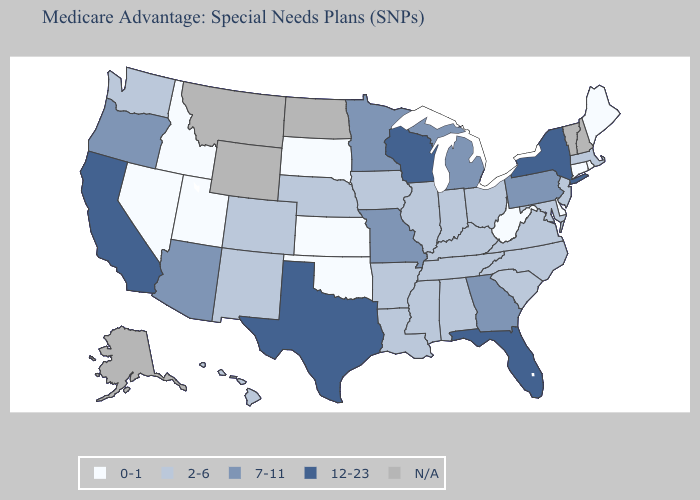Name the states that have a value in the range 12-23?
Answer briefly. California, Florida, New York, Texas, Wisconsin. Among the states that border California , does Nevada have the highest value?
Keep it brief. No. What is the value of Florida?
Short answer required. 12-23. What is the value of Georgia?
Give a very brief answer. 7-11. What is the lowest value in the USA?
Give a very brief answer. 0-1. Which states have the lowest value in the MidWest?
Be succinct. Kansas, South Dakota. Does the map have missing data?
Write a very short answer. Yes. Name the states that have a value in the range N/A?
Short answer required. Alaska, Montana, North Dakota, New Hampshire, Vermont, Wyoming. Does the first symbol in the legend represent the smallest category?
Answer briefly. Yes. What is the value of Wyoming?
Keep it brief. N/A. Does Nevada have the lowest value in the West?
Short answer required. Yes. What is the value of Rhode Island?
Short answer required. 0-1. Name the states that have a value in the range 0-1?
Write a very short answer. Connecticut, Delaware, Idaho, Kansas, Maine, Nevada, Oklahoma, Rhode Island, South Dakota, Utah, West Virginia. Does Rhode Island have the lowest value in the Northeast?
Answer briefly. Yes. 